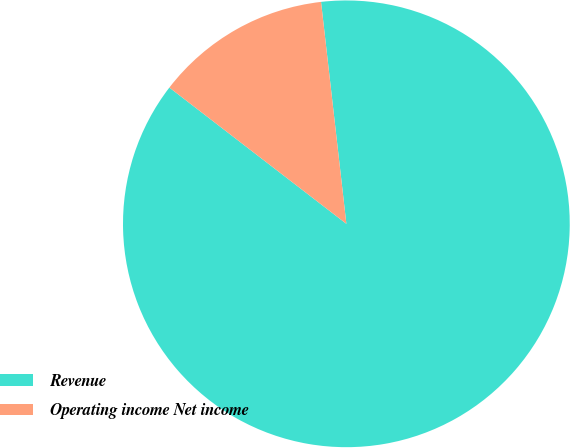<chart> <loc_0><loc_0><loc_500><loc_500><pie_chart><fcel>Revenue<fcel>Operating income Net income<nl><fcel>87.25%<fcel>12.75%<nl></chart> 